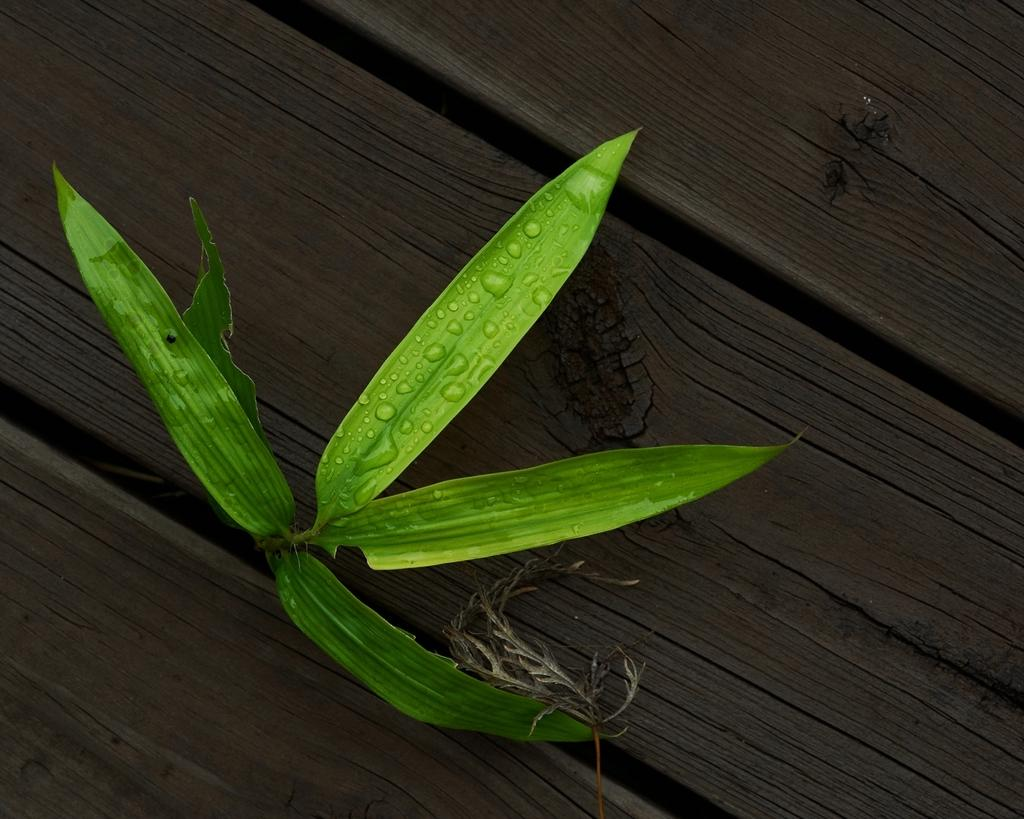What type of surface is visible in the image? There is a wooden surface in the image. What type of plant can be seen in the image? There is a plant with green leaves in the image. How is the plant positioned in relation to the wooden surfaces? The plant is situated between two wooden surfaces. How much dirt is visible beneath the plant in the image? There is no dirt visible beneath the plant in the image; it is situated between two wooden surfaces. 